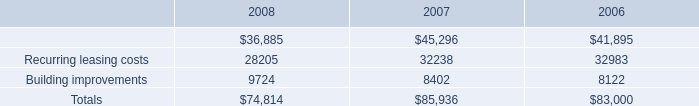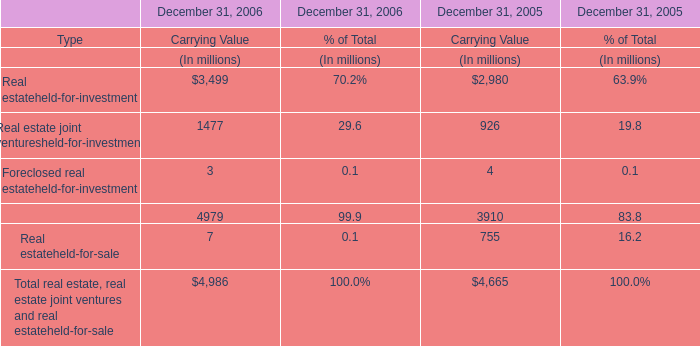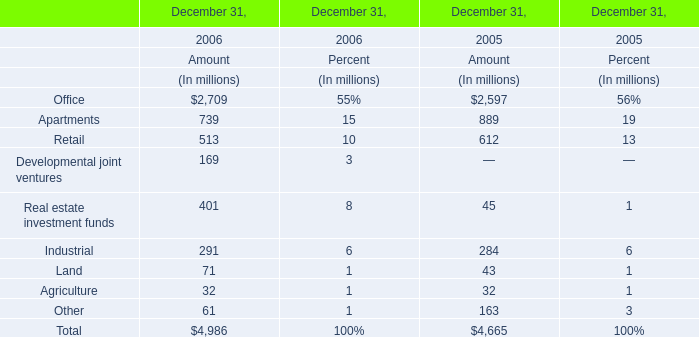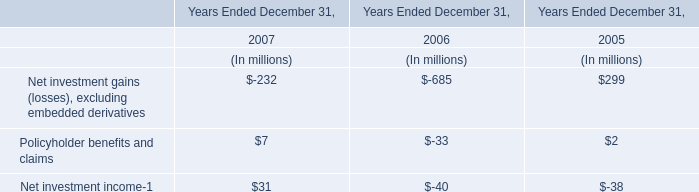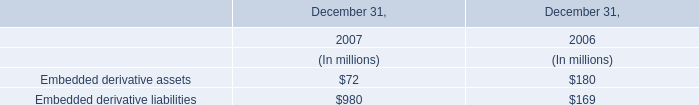What's the increasing rate of Industrial in 2006? (in %) 
Computations: ((291 - 284) / 284)
Answer: 0.02465. 